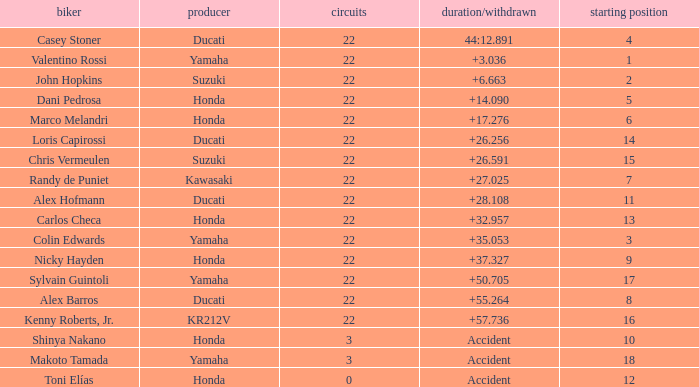What was the average amount of laps for competitors with a grid that was more than 11 and a Time/Retired of +28.108? None. 